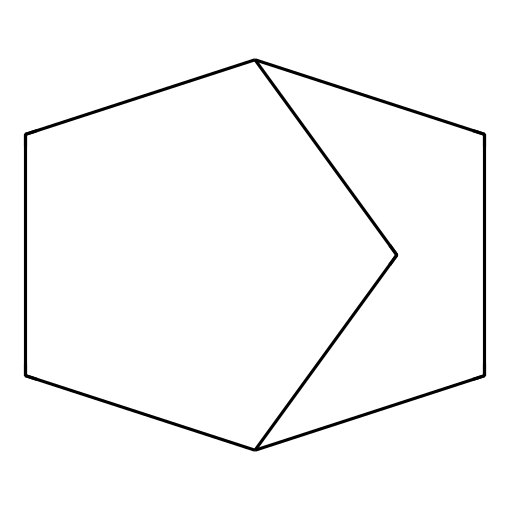What is the molecular formula of norbornane? To determine the molecular formula, count the number of carbon (C) and hydrogen (H) atoms in the structure. The structure has 10 carbon atoms and 16 hydrogen atoms. Therefore, the molecular formula is C10H16.
Answer: C10H16 How many rings does norbornane have? By examining the structure, it is clear that norbornane consists of a single cyclic structure, thus it has one ring.
Answer: one What is the common name for the structural formula represented here? The structure provided corresponds to the cycloalkane known as norbornane, which is commonly referred to by this name in organic chemistry contexts.
Answer: norbornane Is norbornane a saturated or unsaturated compound? Since all carbon-carbon bonds in norbornane are single bonds, it is classified as a saturated compound.
Answer: saturated How does the arrangement of atoms in norbornane affect its stability? The molecular arrangement allows for minimal angle strain and torsional strain, contributing to its stability compared to other structures with similar formulas.
Answer: stability What type of chemical structure does norbornane represent? Norbornane represents a type of cyclic hydrocarbon known specifically as a cycloalkane due to its closed-loop structure consisting entirely of carbon and hydrogen.
Answer: cycloalkane 